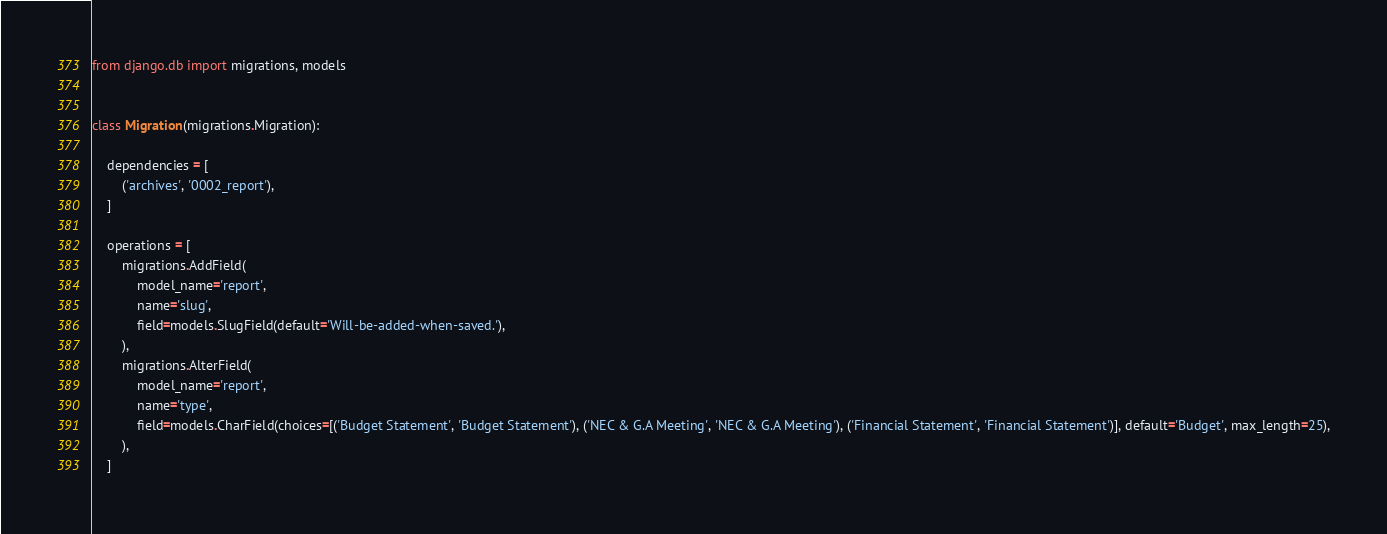Convert code to text. <code><loc_0><loc_0><loc_500><loc_500><_Python_>
from django.db import migrations, models


class Migration(migrations.Migration):

    dependencies = [
        ('archives', '0002_report'),
    ]

    operations = [
        migrations.AddField(
            model_name='report',
            name='slug',
            field=models.SlugField(default='Will-be-added-when-saved.'),
        ),
        migrations.AlterField(
            model_name='report',
            name='type',
            field=models.CharField(choices=[('Budget Statement', 'Budget Statement'), ('NEC & G.A Meeting', 'NEC & G.A Meeting'), ('Financial Statement', 'Financial Statement')], default='Budget', max_length=25),
        ),
    ]
</code> 